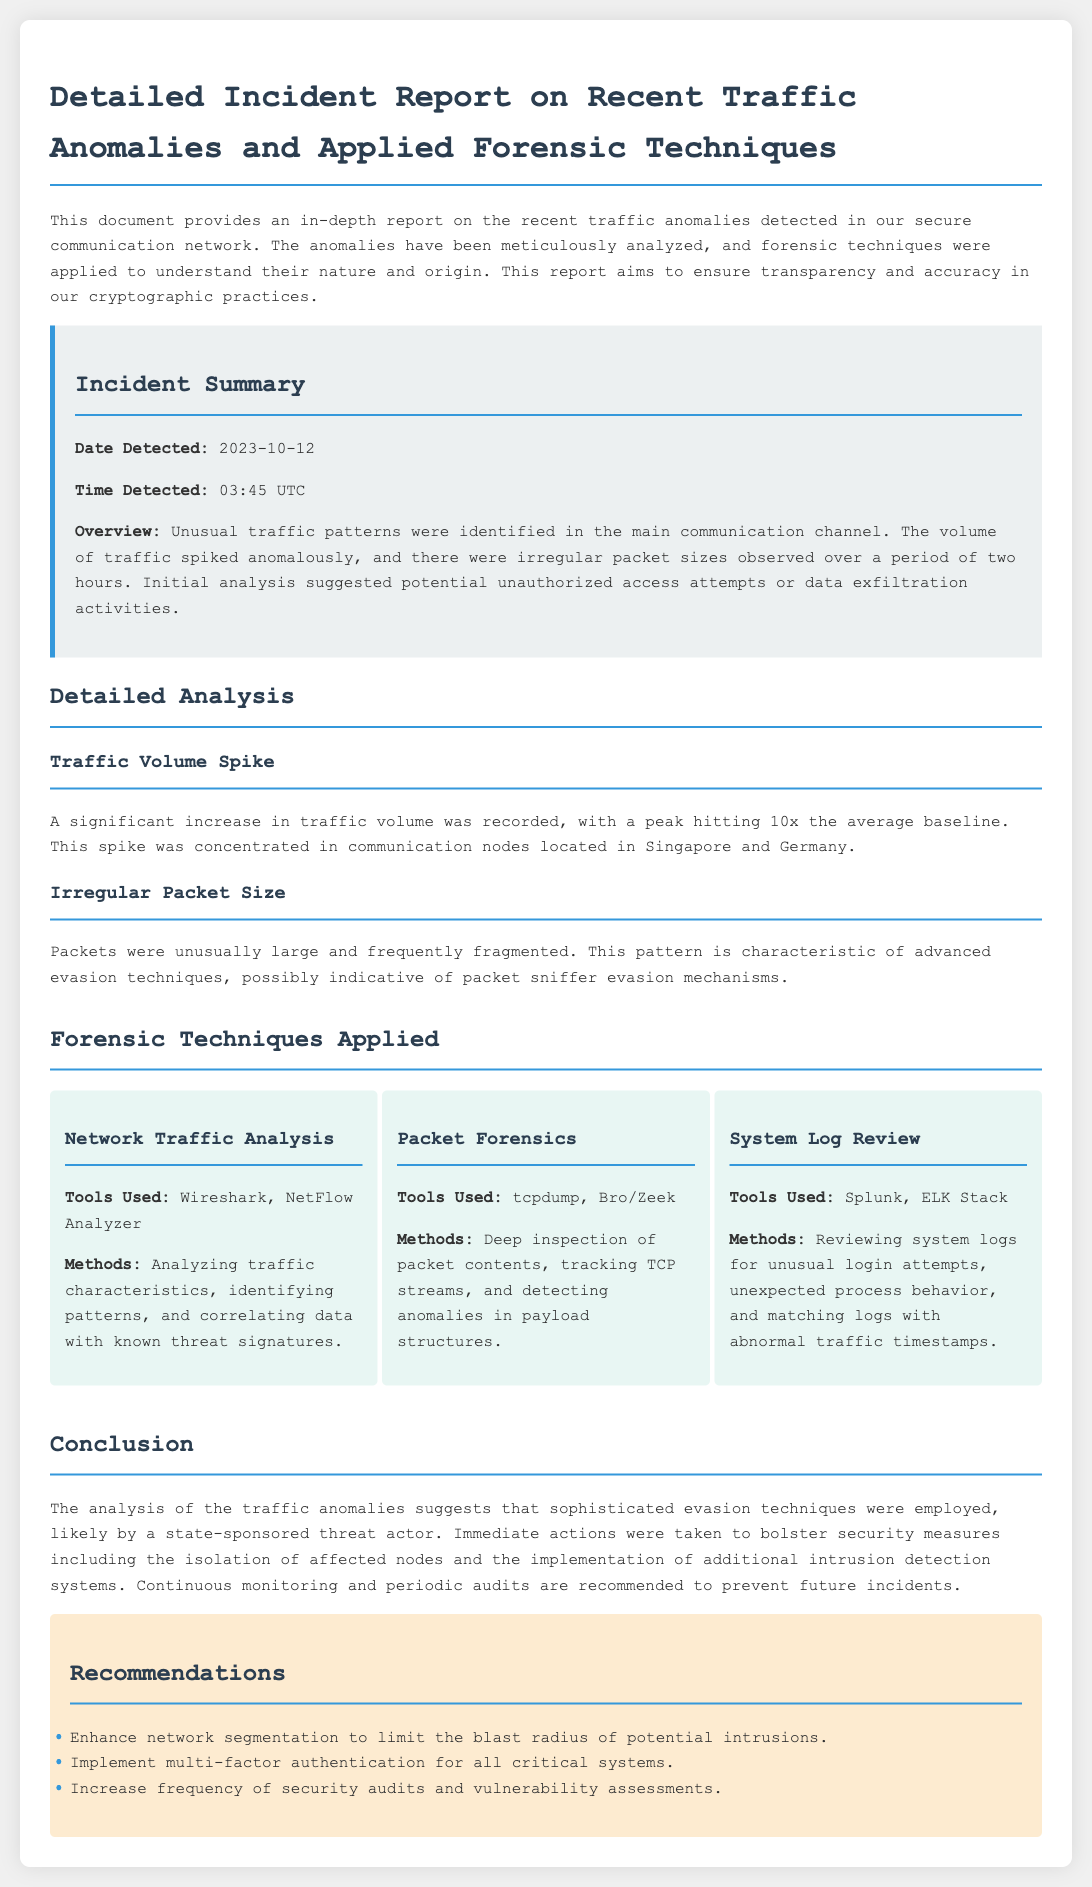What date was the incident detected? The date is explicitly mentioned in the incident summary section of the report, which states "Date Detected: 2023-10-12".
Answer: 2023-10-12 What time was the incident detected? The time is provided in the incident summary, listed as "Time Detected: 03:45 UTC".
Answer: 03:45 UTC What was the peak traffic volume during the incident? The analysis section specifies the traffic volume peak as "10x the average baseline".
Answer: 10x the average baseline Which communication nodes had the traffic spike? The detailed analysis mentions that the traffic spike was concentrated in "communication nodes located in Singapore and Germany".
Answer: Singapore and Germany What forensic technique used tools like Wireshark? The forensic techniques applied section specifies that "Network Traffic Analysis" used tools such as Wireshark.
Answer: Network Traffic Analysis What does the report suggest about the nature of the threat actor? The conclusion indicates that the analysis suggests the involvement of "a state-sponsored threat actor".
Answer: a state-sponsored threat actor How many forensic techniques were applied in the report? By counting the subsections, the report lists three specific techniques in the forensic techniques section.
Answer: Three What security measure is recommended regarding authentication? The recommendations section advises to "Implement multi-factor authentication for all critical systems".
Answer: Multi-factor authentication What was one result of the analysis of the traffic anomalies? The conclusion states that the analysis of the traffic anomalies suggests "sophisticated evasion techniques were employed".
Answer: sophisticated evasion techniques were employed 